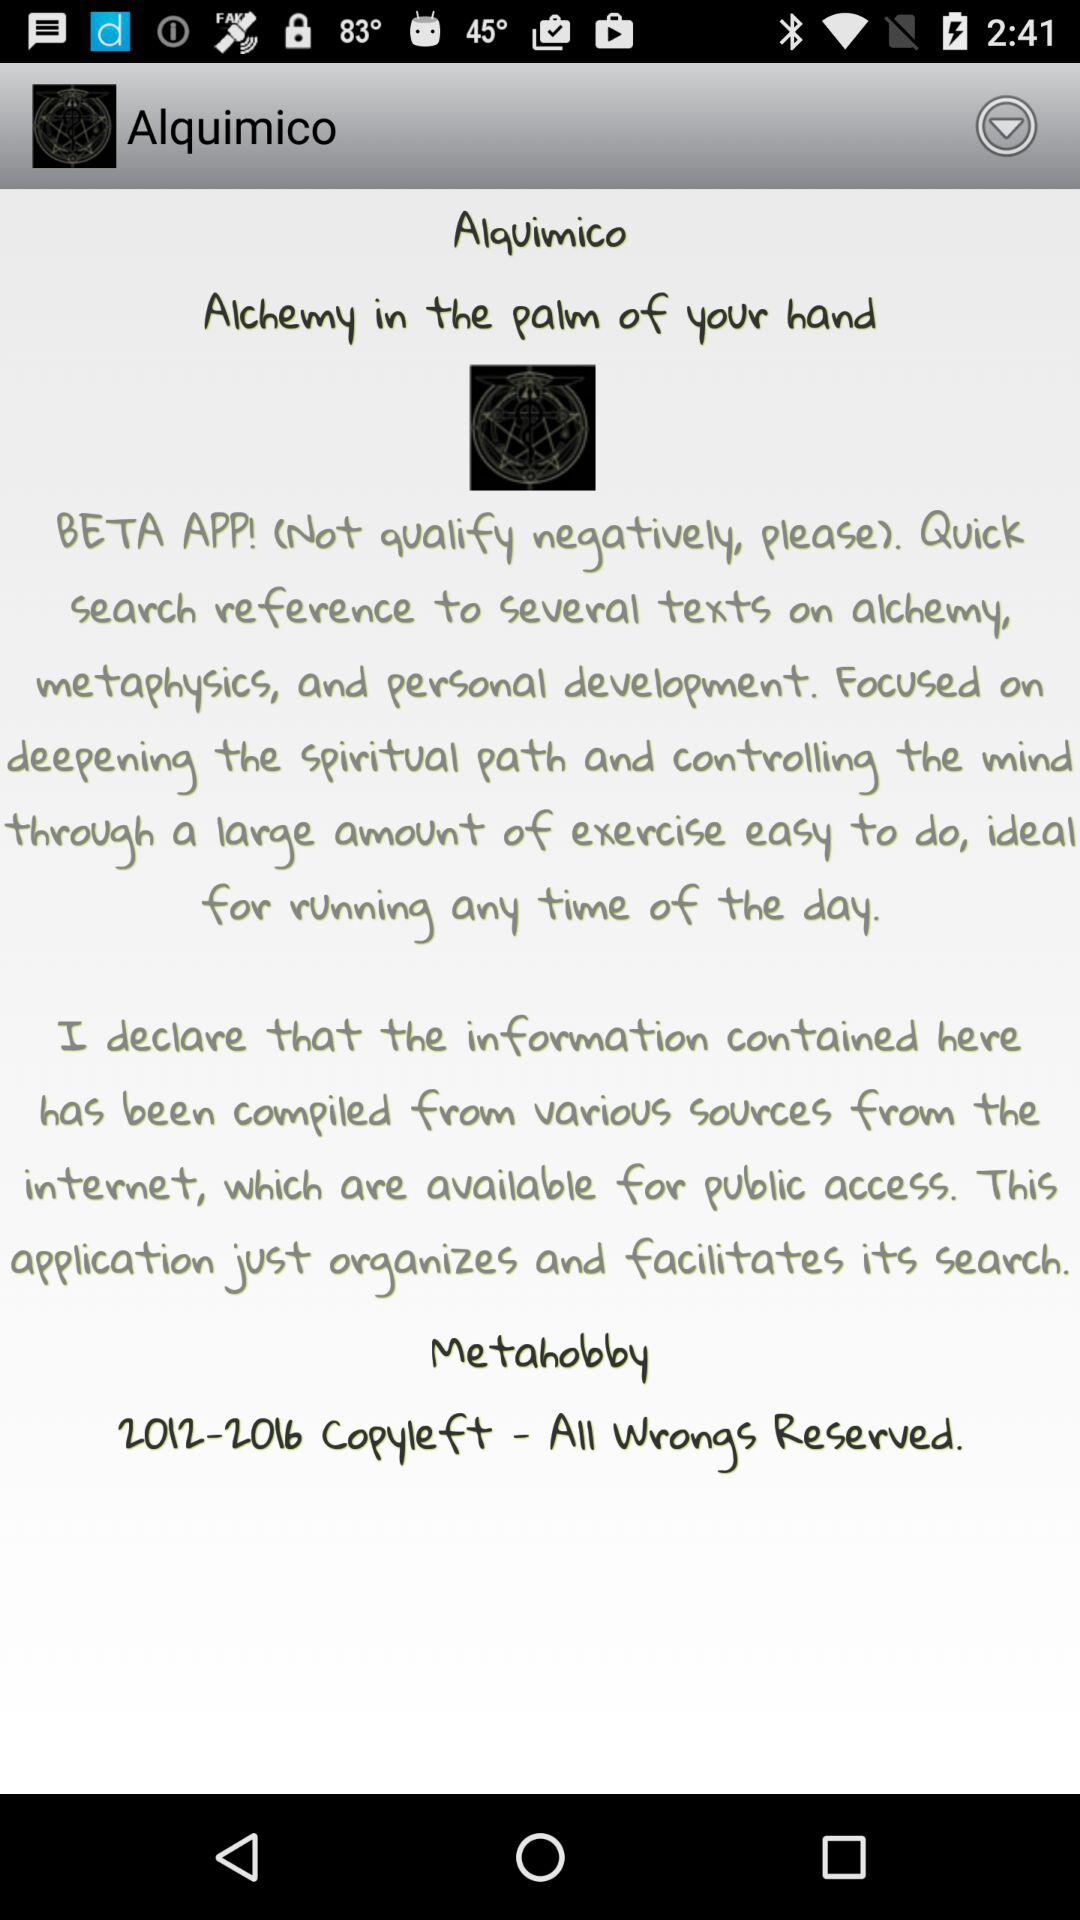What is the application name? The application name is "Alquimico". 